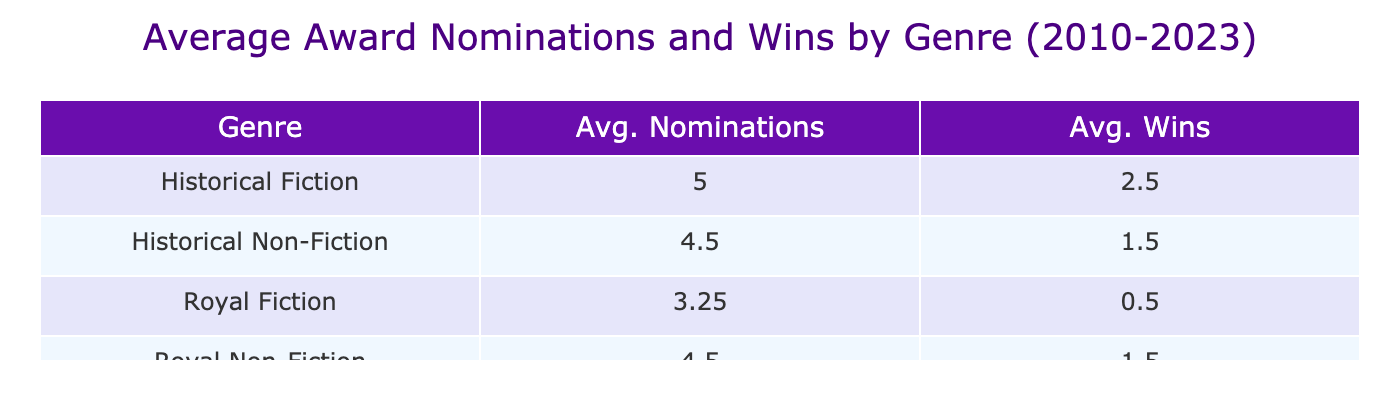What is the average number of award nominations for Royal Fiction? To find the average number of award nominations for Royal Fiction, we identify the relevant data points: 4, 5, 2, and 2. We sum these values (4 + 5 + 2 + 2 = 13) and divide by the number of data points (4), resulting in an average of 13 / 4 = 3.25.
Answer: 3.25 What is the average number of award wins for Historical Non-Fiction? For Historical Non-Fiction, we check the award wins: 1, 2. Their sum is 1 + 2 = 3. We then divide by the number of entries (2), resulting in an average of 3 / 2 = 1.5.
Answer: 1.5 Is it true that Royal Non-Fiction books have more award nominations than Historical Fiction books? The average nominations for Royal Non-Fiction is calculated from 3 and 6, averaging to (3 + 6) / 2 = 4.5. For Historical Fiction, the nominations are 7 and 3, averaging to (7 + 3) / 2 = 5. Since 4.5 is less than 5, it is false.
Answer: No Which genre has the highest average award wins? The categories and their average wins are: Royal Fiction (1), Royal Non-Fiction (1), Historical Fiction (2.5), and Historical Non-Fiction (1.5). Comparing these, Historical Fiction has the highest average with 2.5.
Answer: Historical Fiction What is the difference in average award nominations between Royal Fiction and Historical Non-Fiction? The average nominations for Royal Fiction is 3.25 and for Historical Non-Fiction it is 4. The difference is 4 - 3.25 = 0.75.
Answer: 0.75 Do Royal Fiction books have an average of more than two award wins? Royal Fiction has an average of 1 win across its 4 entries. Since 1 is less than 2, the statement is false.
Answer: No What is the combined average of award nominations for all genres? The combined nominations for all genres are: Royal Fiction (4 + 5 + 2 + 2 = 13), Royal Non-Fiction (3 + 6 = 9), Historical Fiction (7 + 3 = 10), Historical Non-Fiction (5 + 4 = 9). Summing these gives 13 + 9 + 10 + 9 = 41. Dividing by total entries (8), we find the average to be 41 / 8 = 5.125.
Answer: 5.125 Are there any Royal Non-Fiction books that won more than one award? The award wins for Royal Non-Fiction are 2 and 1. Since one of them (2) is more than one, the statement is true.
Answer: Yes 